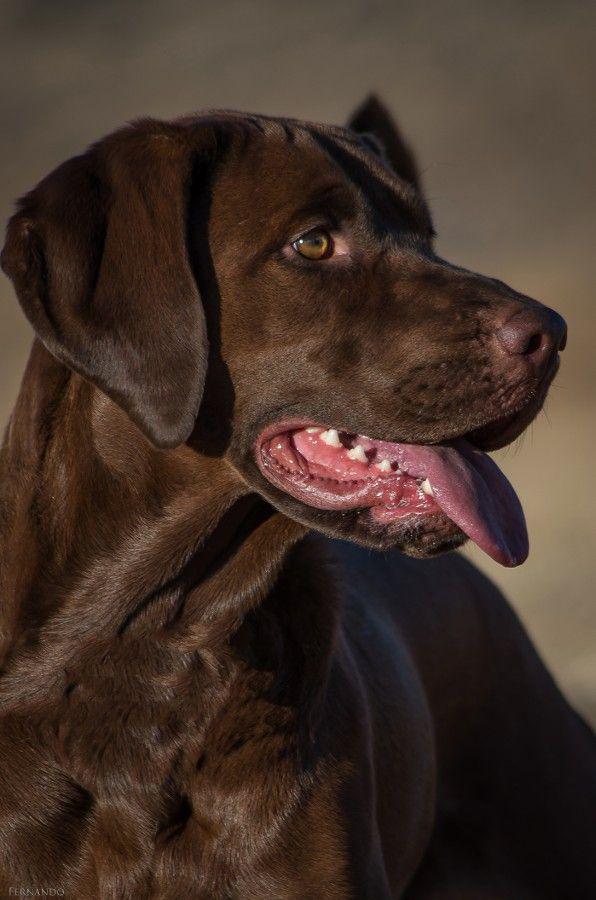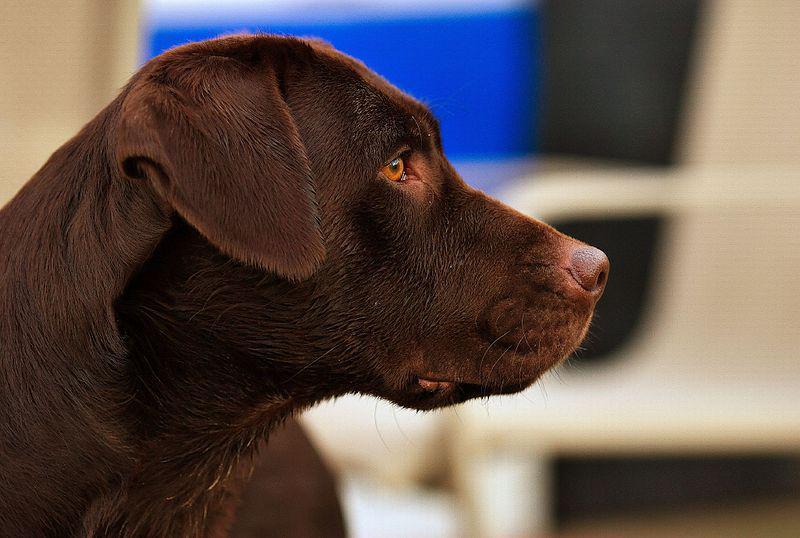The first image is the image on the left, the second image is the image on the right. Given the left and right images, does the statement "There is no more than four dogs." hold true? Answer yes or no. Yes. The first image is the image on the left, the second image is the image on the right. For the images displayed, is the sentence "At least one of the images in each set features a lone black pup." factually correct? Answer yes or no. No. 